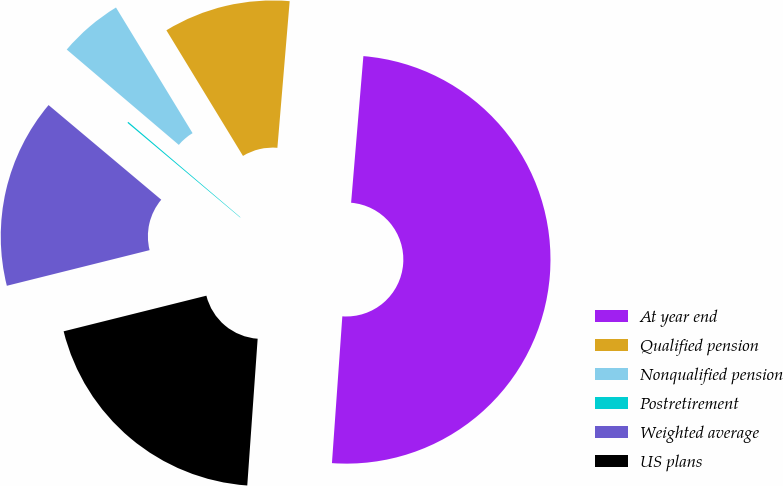Convert chart. <chart><loc_0><loc_0><loc_500><loc_500><pie_chart><fcel>At year end<fcel>Qualified pension<fcel>Nonqualified pension<fcel>Postretirement<fcel>Weighted average<fcel>US plans<nl><fcel>49.79%<fcel>10.04%<fcel>5.07%<fcel>0.1%<fcel>15.01%<fcel>19.98%<nl></chart> 